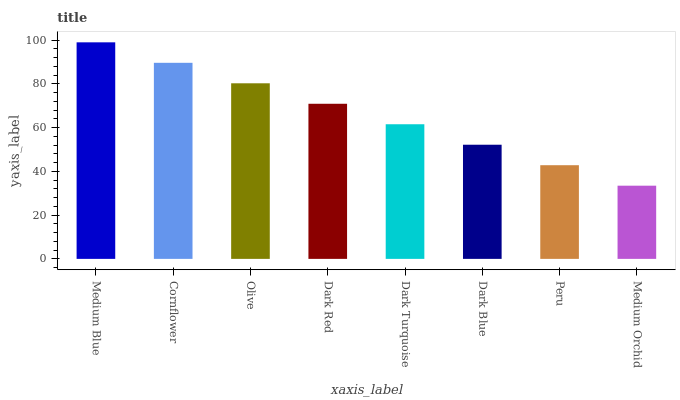Is Medium Orchid the minimum?
Answer yes or no. Yes. Is Medium Blue the maximum?
Answer yes or no. Yes. Is Cornflower the minimum?
Answer yes or no. No. Is Cornflower the maximum?
Answer yes or no. No. Is Medium Blue greater than Cornflower?
Answer yes or no. Yes. Is Cornflower less than Medium Blue?
Answer yes or no. Yes. Is Cornflower greater than Medium Blue?
Answer yes or no. No. Is Medium Blue less than Cornflower?
Answer yes or no. No. Is Dark Red the high median?
Answer yes or no. Yes. Is Dark Turquoise the low median?
Answer yes or no. Yes. Is Medium Blue the high median?
Answer yes or no. No. Is Medium Blue the low median?
Answer yes or no. No. 